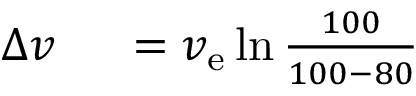<formula> <loc_0><loc_0><loc_500><loc_500>\begin{array} { r l } { \Delta v \ } & = v _ { e } \ln { \frac { 1 0 0 } { 1 0 0 - 8 0 } } } \end{array}</formula> 